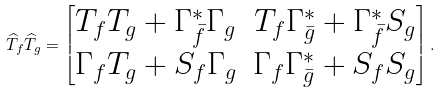<formula> <loc_0><loc_0><loc_500><loc_500>\widehat { T } _ { f } \widehat { T } _ { g } = \begin{bmatrix} T _ { f } T _ { g } + { \Gamma ^ { * } _ { \bar { f } } } { \Gamma _ { g } } & T _ { f } { \Gamma ^ { * } _ { \bar { g } } } + { \Gamma ^ { * } _ { \bar { f } } } { S _ { g } } \\ \Gamma _ { f } T _ { g } + S _ { f } { \Gamma _ { g } } & \Gamma _ { f } { \Gamma ^ { * } _ { \bar { g } } } + S _ { f } S _ { g } \end{bmatrix} .</formula> 